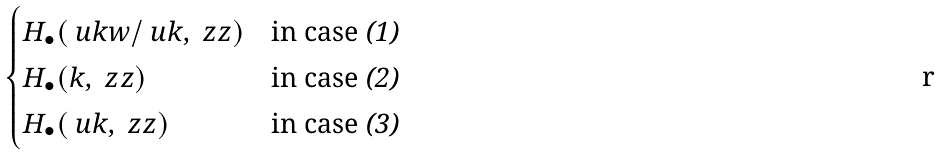<formula> <loc_0><loc_0><loc_500><loc_500>\begin{cases} H _ { \bullet } ( \ u k w / \ u k , \ z z ) & \text {in case {\em (1)}} \\ H _ { \bullet } ( k , \ z z ) & \text {in case {\em (2)}} \\ H _ { \bullet } ( \ u k , \ z z ) & \text {in case {\em (3)}} \end{cases}</formula> 